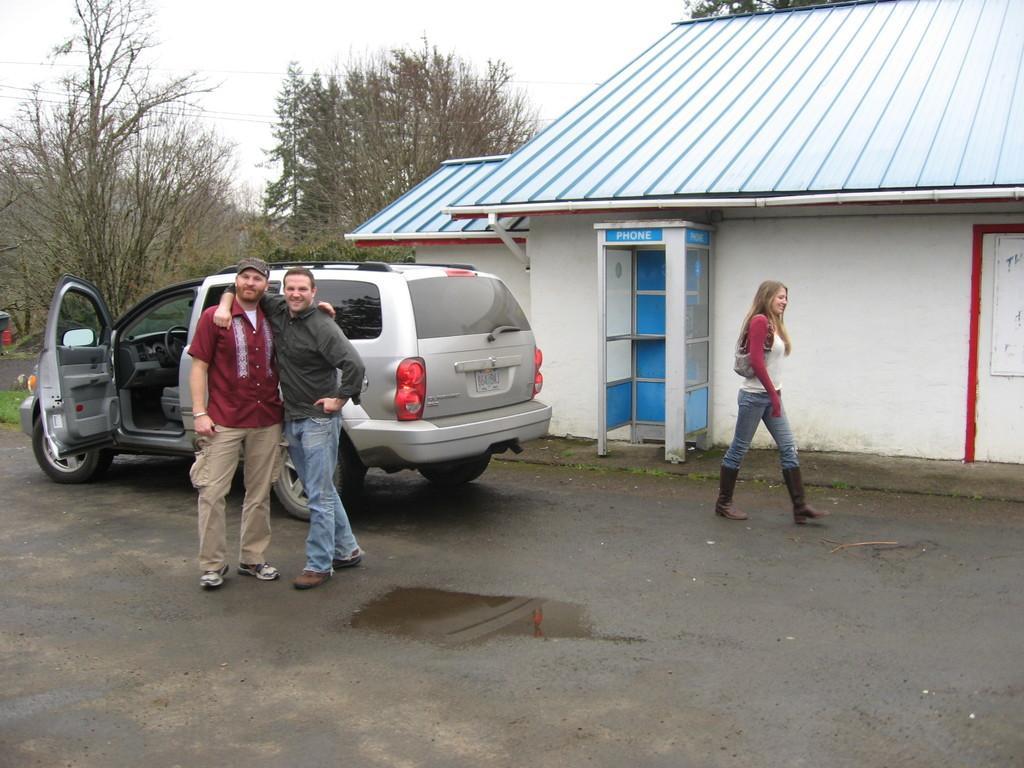Describe this image in one or two sentences. This is the picture of a place where have three people, car, house and around there are some trees. 